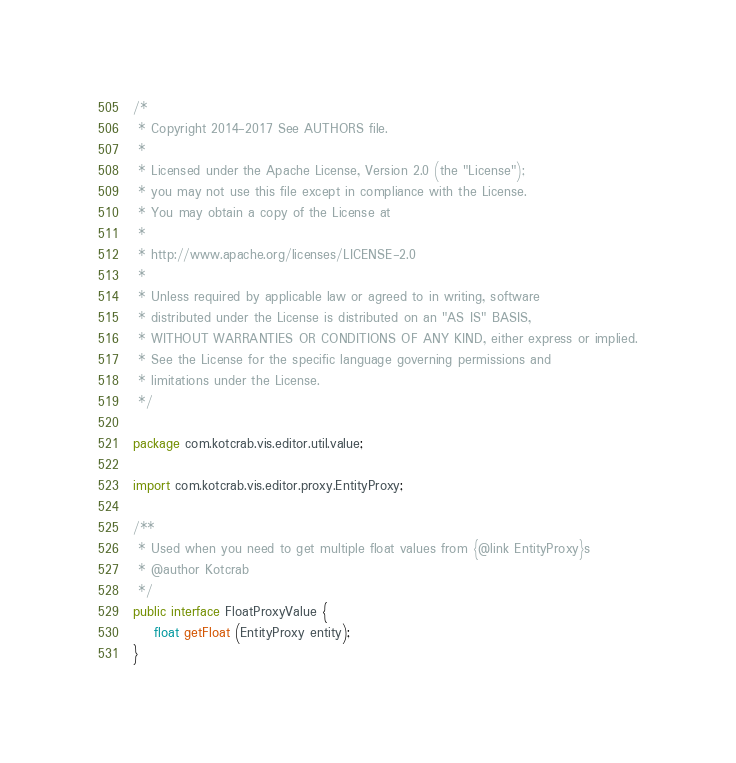Convert code to text. <code><loc_0><loc_0><loc_500><loc_500><_Java_>/*
 * Copyright 2014-2017 See AUTHORS file.
 *
 * Licensed under the Apache License, Version 2.0 (the "License");
 * you may not use this file except in compliance with the License.
 * You may obtain a copy of the License at
 *
 * http://www.apache.org/licenses/LICENSE-2.0
 *
 * Unless required by applicable law or agreed to in writing, software
 * distributed under the License is distributed on an "AS IS" BASIS,
 * WITHOUT WARRANTIES OR CONDITIONS OF ANY KIND, either express or implied.
 * See the License for the specific language governing permissions and
 * limitations under the License.
 */

package com.kotcrab.vis.editor.util.value;

import com.kotcrab.vis.editor.proxy.EntityProxy;

/**
 * Used when you need to get multiple float values from {@link EntityProxy}s
 * @author Kotcrab
 */
public interface FloatProxyValue {
	float getFloat (EntityProxy entity);
}
</code> 